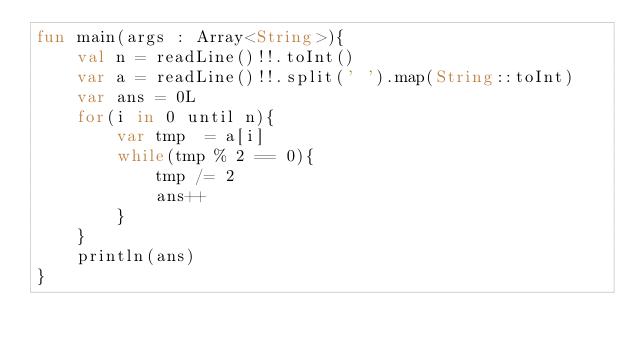Convert code to text. <code><loc_0><loc_0><loc_500><loc_500><_Kotlin_>fun main(args : Array<String>){
    val n = readLine()!!.toInt()
    var a = readLine()!!.split(' ').map(String::toInt)
    var ans = 0L
    for(i in 0 until n){
        var tmp  = a[i]
        while(tmp % 2 == 0){
            tmp /= 2
            ans++
        }
    }
    println(ans)
}</code> 